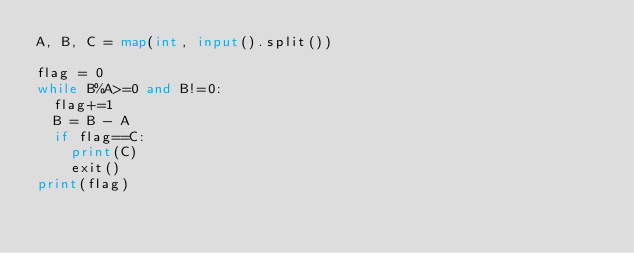<code> <loc_0><loc_0><loc_500><loc_500><_Python_>A, B, C = map(int, input().split())

flag = 0
while B%A>=0 and B!=0:
	flag+=1
	B = B - A
	if flag==C:
		print(C)
		exit()
print(flag)</code> 